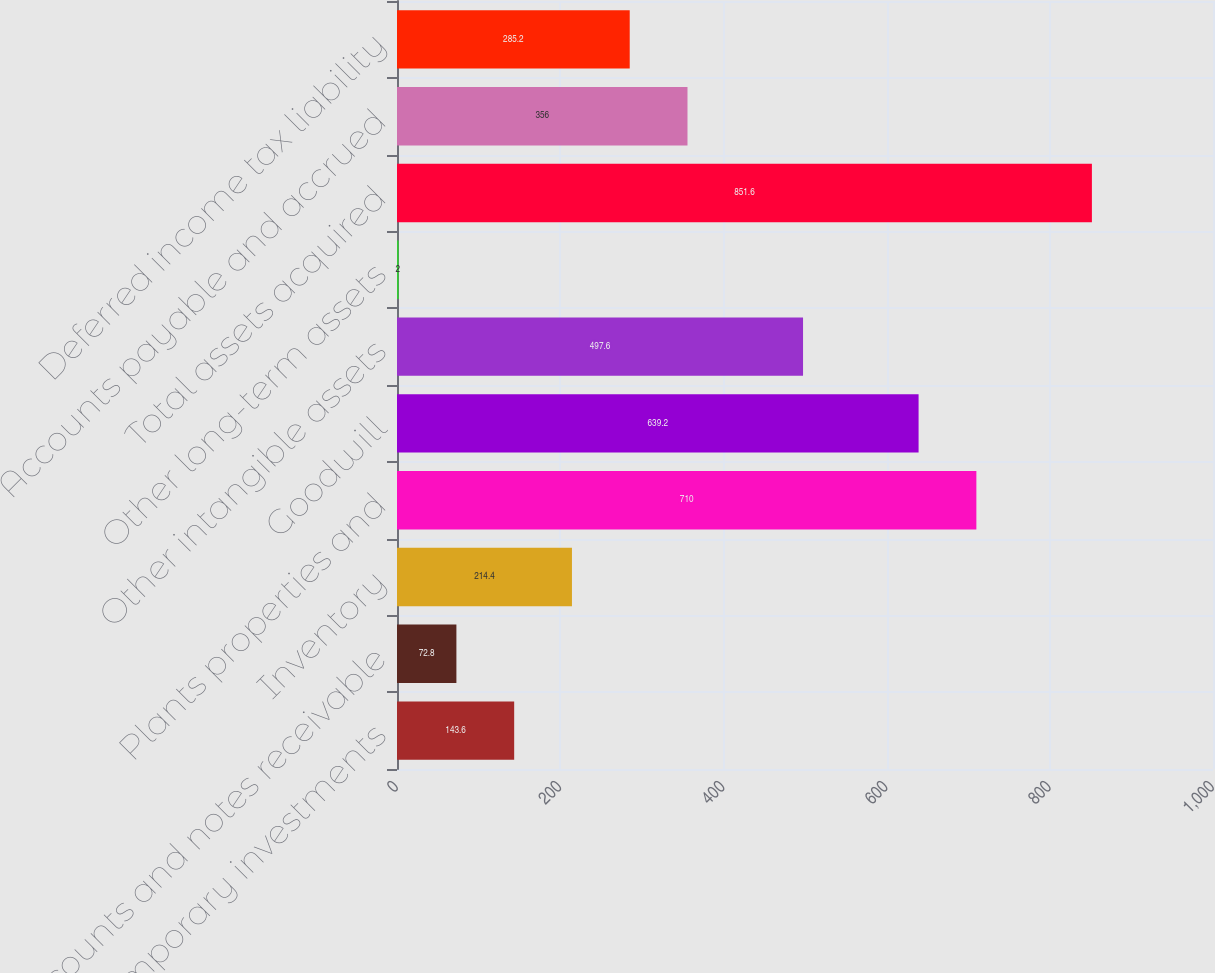<chart> <loc_0><loc_0><loc_500><loc_500><bar_chart><fcel>Cash and temporary investments<fcel>Accounts and notes receivable<fcel>Inventory<fcel>Plants properties and<fcel>Goodwill<fcel>Other intangible assets<fcel>Other long-term assets<fcel>Total assets acquired<fcel>Accounts payable and accrued<fcel>Deferred income tax liability<nl><fcel>143.6<fcel>72.8<fcel>214.4<fcel>710<fcel>639.2<fcel>497.6<fcel>2<fcel>851.6<fcel>356<fcel>285.2<nl></chart> 